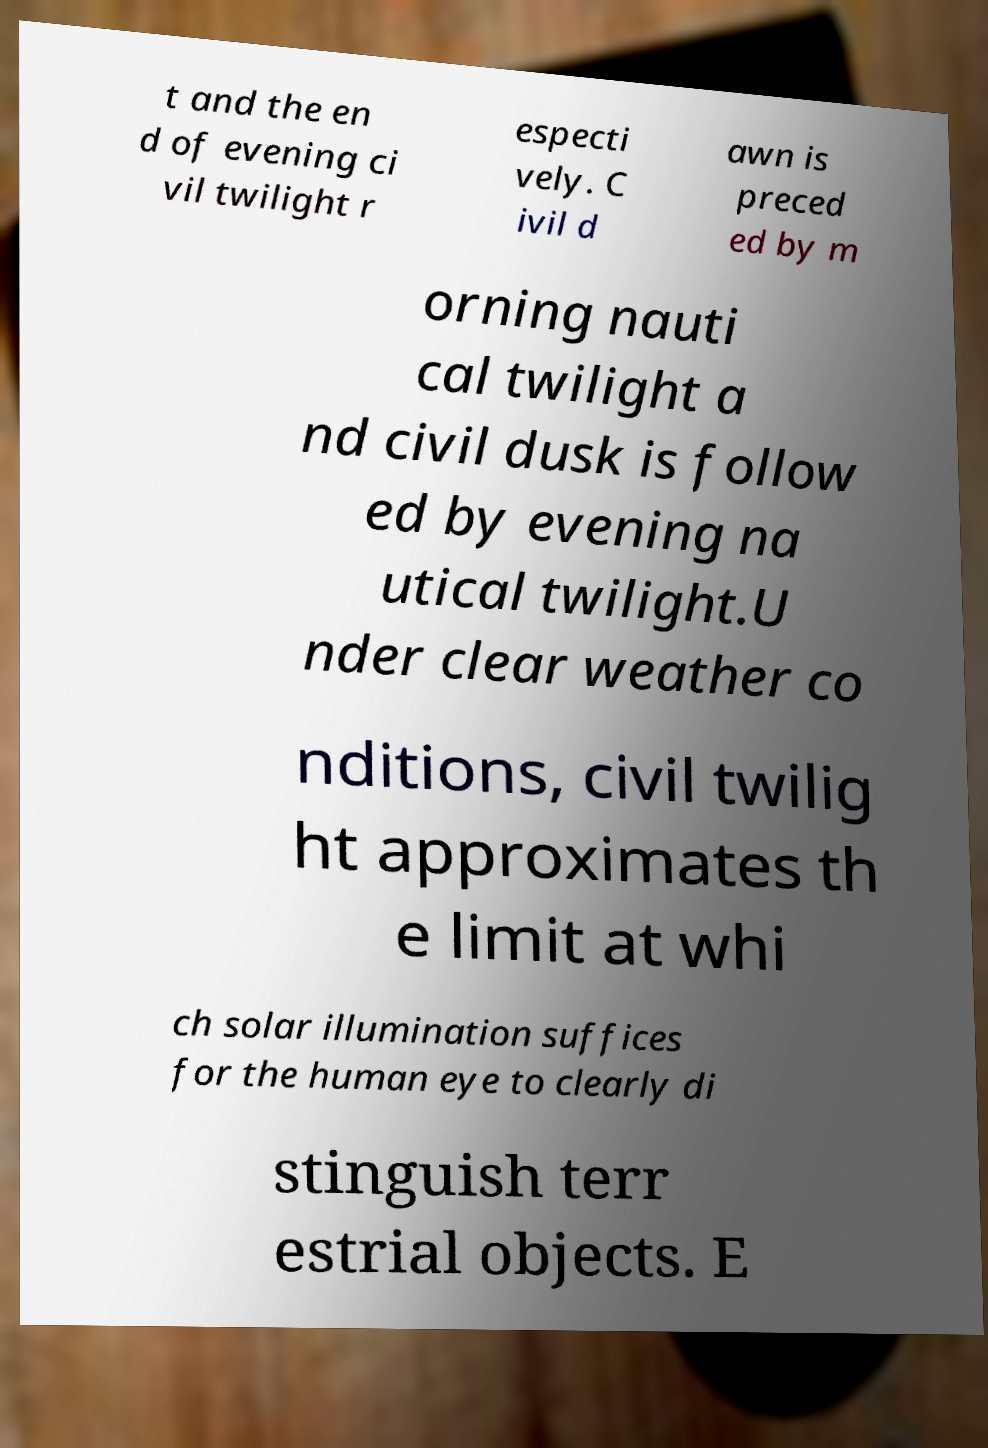I need the written content from this picture converted into text. Can you do that? t and the en d of evening ci vil twilight r especti vely. C ivil d awn is preced ed by m orning nauti cal twilight a nd civil dusk is follow ed by evening na utical twilight.U nder clear weather co nditions, civil twilig ht approximates th e limit at whi ch solar illumination suffices for the human eye to clearly di stinguish terr estrial objects. E 